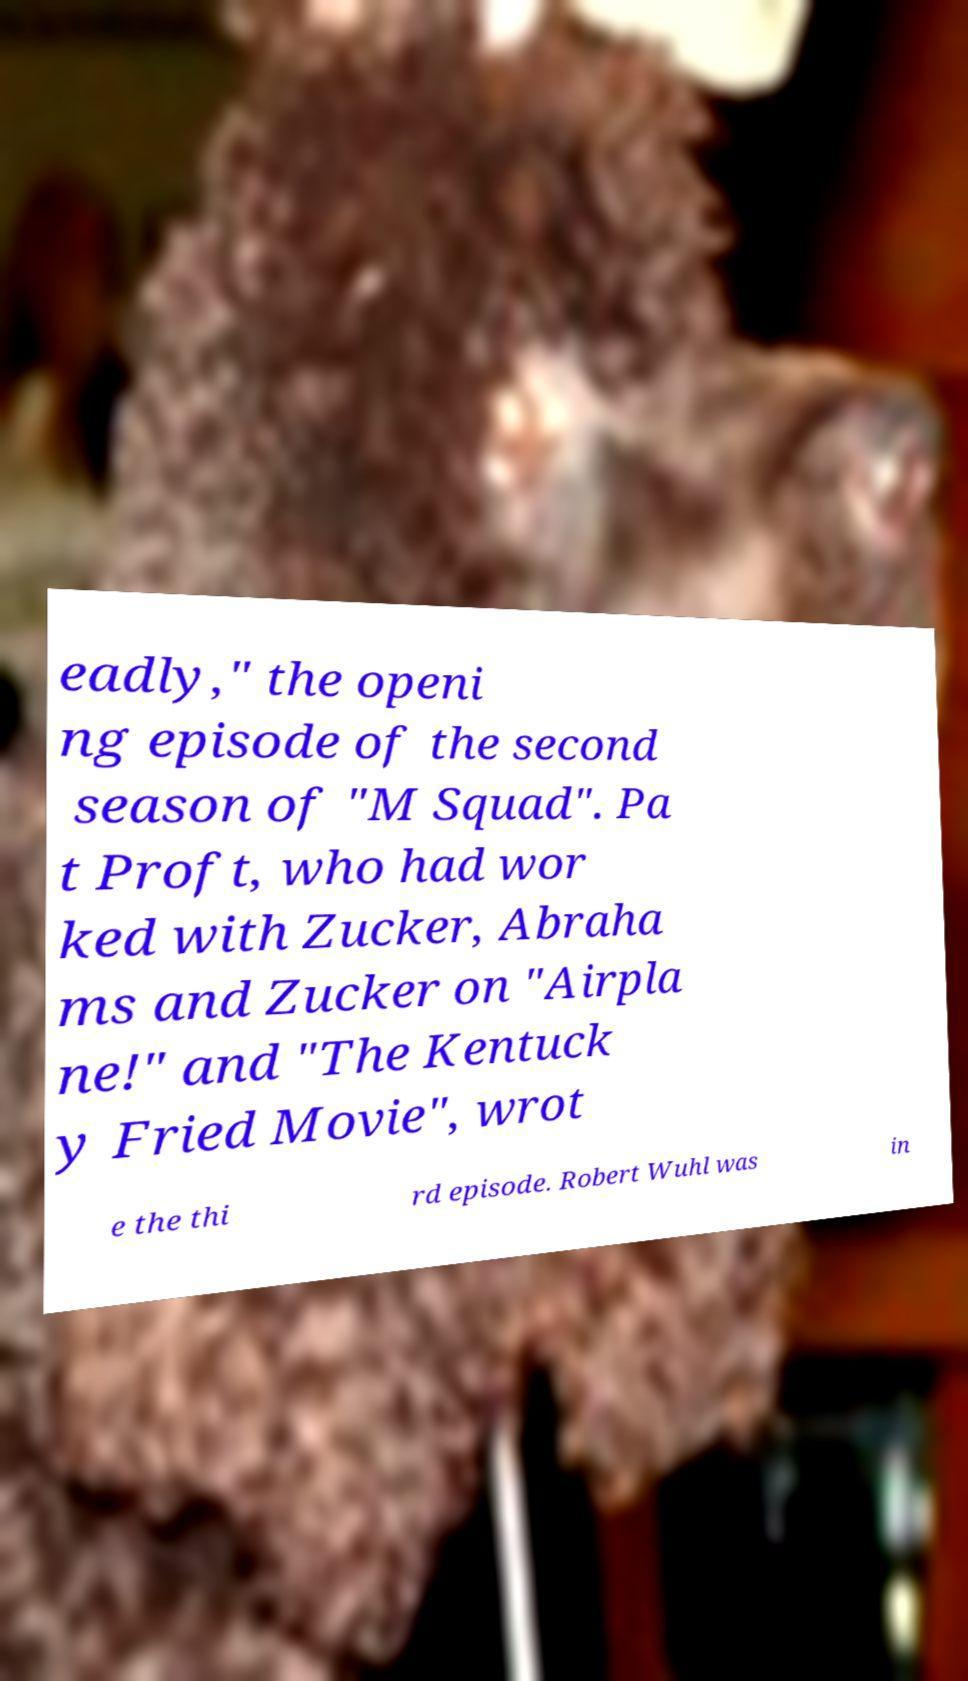Could you assist in decoding the text presented in this image and type it out clearly? eadly," the openi ng episode of the second season of "M Squad". Pa t Proft, who had wor ked with Zucker, Abraha ms and Zucker on "Airpla ne!" and "The Kentuck y Fried Movie", wrot e the thi rd episode. Robert Wuhl was in 